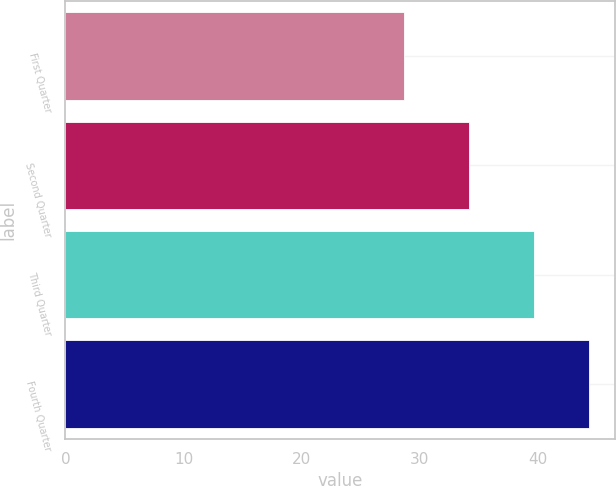Convert chart to OTSL. <chart><loc_0><loc_0><loc_500><loc_500><bar_chart><fcel>First Quarter<fcel>Second Quarter<fcel>Third Quarter<fcel>Fourth Quarter<nl><fcel>28.67<fcel>34.17<fcel>39.68<fcel>44.33<nl></chart> 